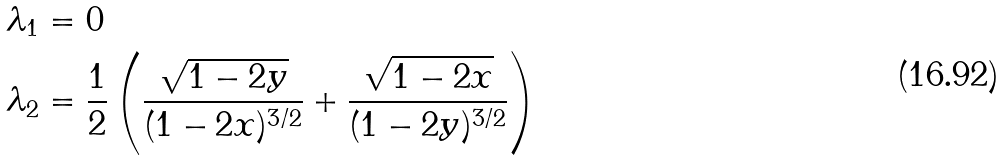Convert formula to latex. <formula><loc_0><loc_0><loc_500><loc_500>\lambda _ { 1 } & = 0 \\ \lambda _ { 2 } & = \frac { 1 } { 2 } \left ( \frac { \sqrt { 1 - 2 y } } { ( 1 - 2 x ) ^ { 3 / 2 } } + \frac { \sqrt { 1 - 2 x } } { ( 1 - 2 y ) ^ { 3 / 2 } } \right )</formula> 